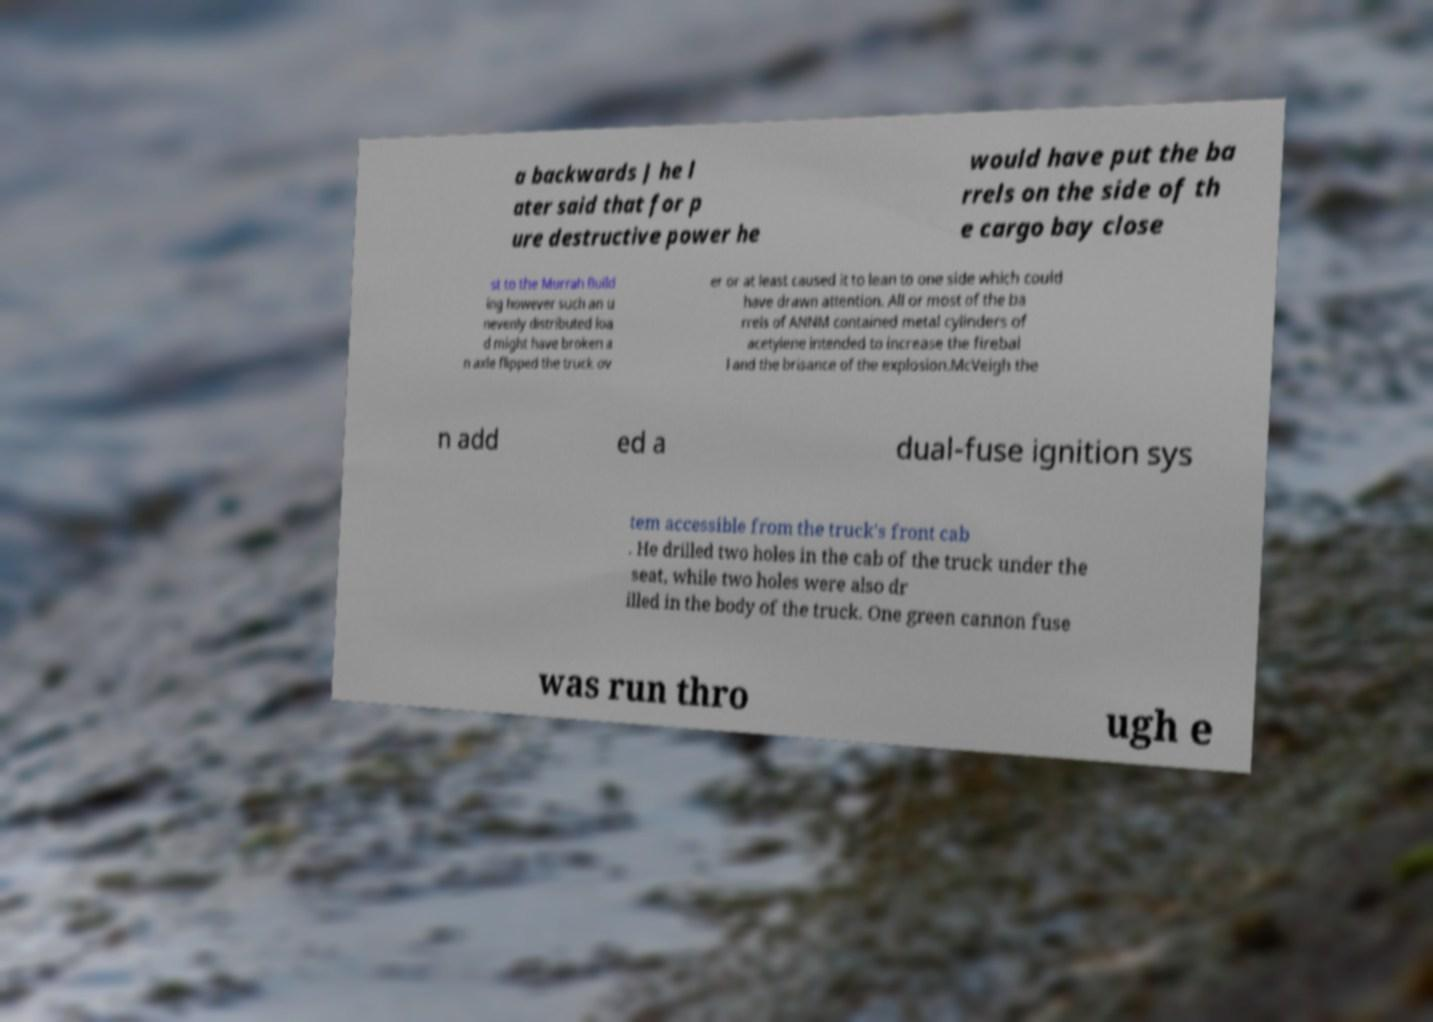What messages or text are displayed in this image? I need them in a readable, typed format. a backwards J he l ater said that for p ure destructive power he would have put the ba rrels on the side of th e cargo bay close st to the Murrah Build ing however such an u nevenly distributed loa d might have broken a n axle flipped the truck ov er or at least caused it to lean to one side which could have drawn attention. All or most of the ba rrels of ANNM contained metal cylinders of acetylene intended to increase the firebal l and the brisance of the explosion.McVeigh the n add ed a dual-fuse ignition sys tem accessible from the truck's front cab . He drilled two holes in the cab of the truck under the seat, while two holes were also dr illed in the body of the truck. One green cannon fuse was run thro ugh e 